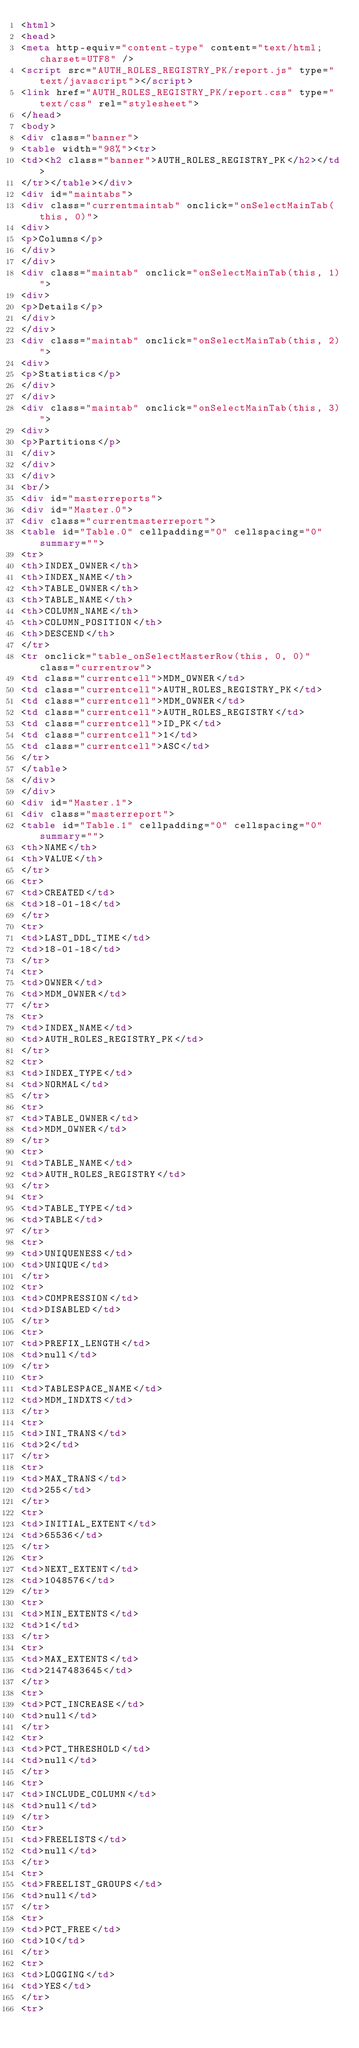<code> <loc_0><loc_0><loc_500><loc_500><_HTML_><html>
<head>
<meta http-equiv="content-type" content="text/html; charset=UTF8" />
<script src="AUTH_ROLES_REGISTRY_PK/report.js" type="text/javascript"></script>
<link href="AUTH_ROLES_REGISTRY_PK/report.css" type="text/css" rel="stylesheet">
</head>
<body>
<div class="banner">
<table width="98%"><tr>
<td><h2 class="banner">AUTH_ROLES_REGISTRY_PK</h2></td>
</tr></table></div>
<div id="maintabs">
<div class="currentmaintab" onclick="onSelectMainTab(this, 0)">
<div>
<p>Columns</p>
</div>
</div>
<div class="maintab" onclick="onSelectMainTab(this, 1)">
<div>
<p>Details</p>
</div>
</div>
<div class="maintab" onclick="onSelectMainTab(this, 2)">
<div>
<p>Statistics</p>
</div>
</div>
<div class="maintab" onclick="onSelectMainTab(this, 3)">
<div>
<p>Partitions</p>
</div>
</div>
</div>
<br/>
<div id="masterreports">
<div id="Master.0">
<div class="currentmasterreport">
<table id="Table.0" cellpadding="0" cellspacing="0" summary="">
<tr>
<th>INDEX_OWNER</th>
<th>INDEX_NAME</th>
<th>TABLE_OWNER</th>
<th>TABLE_NAME</th>
<th>COLUMN_NAME</th>
<th>COLUMN_POSITION</th>
<th>DESCEND</th>
</tr>
<tr onclick="table_onSelectMasterRow(this, 0, 0)" class="currentrow">
<td class="currentcell">MDM_OWNER</td>
<td class="currentcell">AUTH_ROLES_REGISTRY_PK</td>
<td class="currentcell">MDM_OWNER</td>
<td class="currentcell">AUTH_ROLES_REGISTRY</td>
<td class="currentcell">ID_PK</td>
<td class="currentcell">1</td>
<td class="currentcell">ASC</td>
</tr>
</table>
</div>
</div>
<div id="Master.1">
<div class="masterreport">
<table id="Table.1" cellpadding="0" cellspacing="0" summary="">
<th>NAME</th>
<th>VALUE</th>
</tr>
<tr>
<td>CREATED</td>
<td>18-01-18</td>
</tr>
<tr>
<td>LAST_DDL_TIME</td>
<td>18-01-18</td>
</tr>
<tr>
<td>OWNER</td>
<td>MDM_OWNER</td>
</tr>
<tr>
<td>INDEX_NAME</td>
<td>AUTH_ROLES_REGISTRY_PK</td>
</tr>
<tr>
<td>INDEX_TYPE</td>
<td>NORMAL</td>
</tr>
<tr>
<td>TABLE_OWNER</td>
<td>MDM_OWNER</td>
</tr>
<tr>
<td>TABLE_NAME</td>
<td>AUTH_ROLES_REGISTRY</td>
</tr>
<tr>
<td>TABLE_TYPE</td>
<td>TABLE</td>
</tr>
<tr>
<td>UNIQUENESS</td>
<td>UNIQUE</td>
</tr>
<tr>
<td>COMPRESSION</td>
<td>DISABLED</td>
</tr>
<tr>
<td>PREFIX_LENGTH</td>
<td>null</td>
</tr>
<tr>
<td>TABLESPACE_NAME</td>
<td>MDM_INDXTS</td>
</tr>
<tr>
<td>INI_TRANS</td>
<td>2</td>
</tr>
<tr>
<td>MAX_TRANS</td>
<td>255</td>
</tr>
<tr>
<td>INITIAL_EXTENT</td>
<td>65536</td>
</tr>
<tr>
<td>NEXT_EXTENT</td>
<td>1048576</td>
</tr>
<tr>
<td>MIN_EXTENTS</td>
<td>1</td>
</tr>
<tr>
<td>MAX_EXTENTS</td>
<td>2147483645</td>
</tr>
<tr>
<td>PCT_INCREASE</td>
<td>null</td>
</tr>
<tr>
<td>PCT_THRESHOLD</td>
<td>null</td>
</tr>
<tr>
<td>INCLUDE_COLUMN</td>
<td>null</td>
</tr>
<tr>
<td>FREELISTS</td>
<td>null</td>
</tr>
<tr>
<td>FREELIST_GROUPS</td>
<td>null</td>
</tr>
<tr>
<td>PCT_FREE</td>
<td>10</td>
</tr>
<tr>
<td>LOGGING</td>
<td>YES</td>
</tr>
<tr></code> 